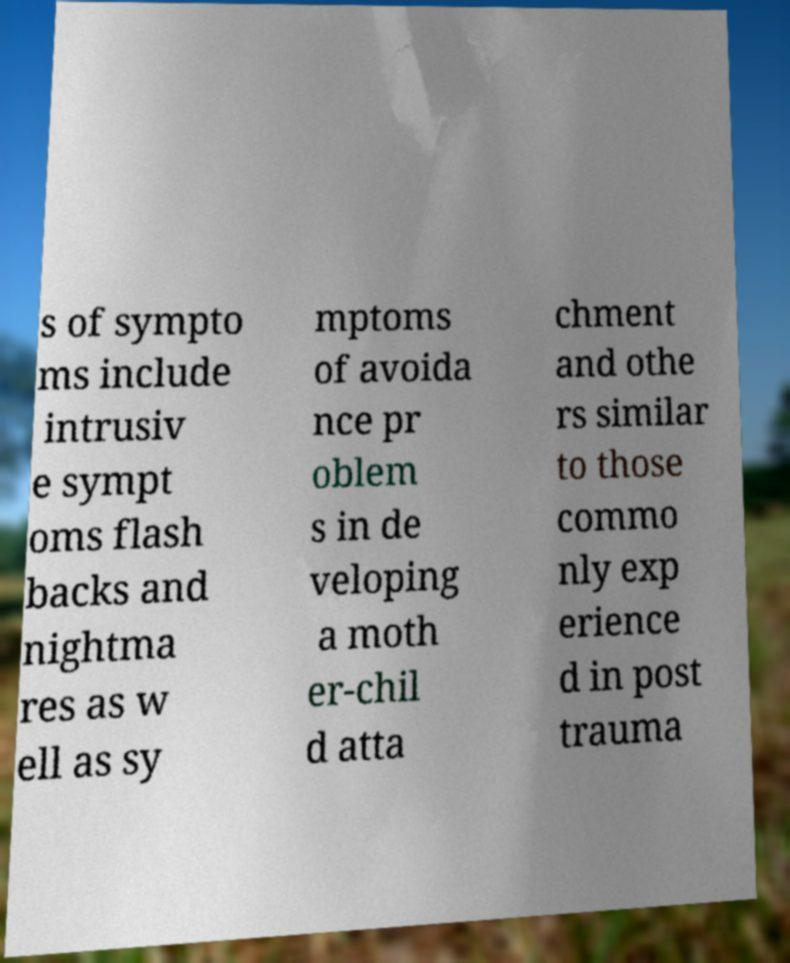What messages or text are displayed in this image? I need them in a readable, typed format. s of sympto ms include intrusiv e sympt oms flash backs and nightma res as w ell as sy mptoms of avoida nce pr oblem s in de veloping a moth er-chil d atta chment and othe rs similar to those commo nly exp erience d in post trauma 